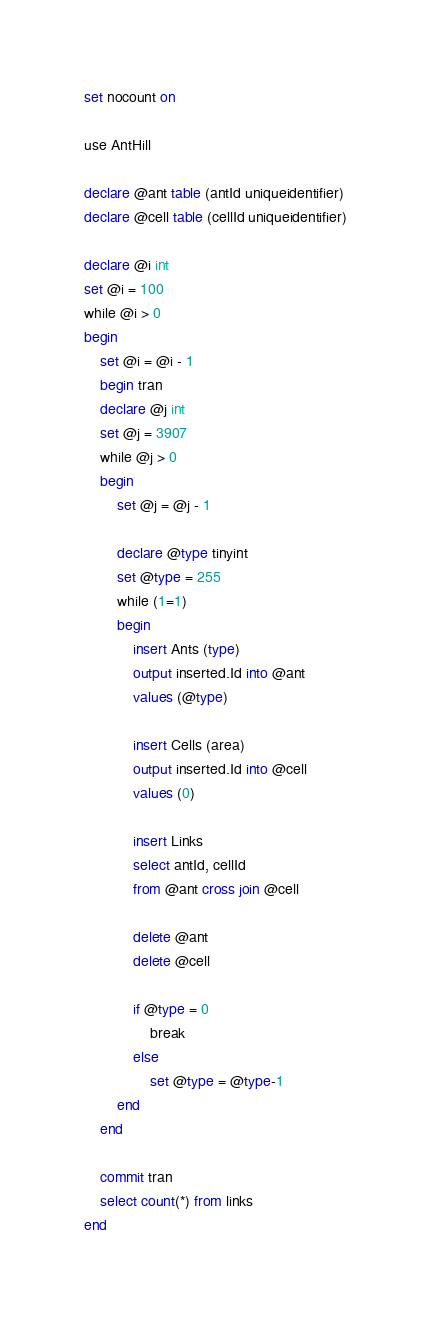Convert code to text. <code><loc_0><loc_0><loc_500><loc_500><_SQL_>set nocount on

use AntHill

declare @ant table (antId uniqueidentifier)
declare @cell table (cellId uniqueidentifier)

declare @i int
set @i = 100
while @i > 0
begin
	set @i = @i - 1
	begin tran
	declare @j int
	set @j = 3907
	while @j > 0
	begin
		set @j = @j - 1

		declare @type tinyint
		set @type = 255
		while (1=1)
		begin
			insert Ants (type)
			output inserted.Id into @ant
			values (@type)

			insert Cells (area)
			output inserted.Id into @cell
			values (0)

			insert Links
			select antId, cellId
			from @ant cross join @cell

			delete @ant
			delete @cell
			
			if @type = 0
				break
			else
				set @type = @type-1
		end
	end

	commit tran
	select count(*) from links
end</code> 